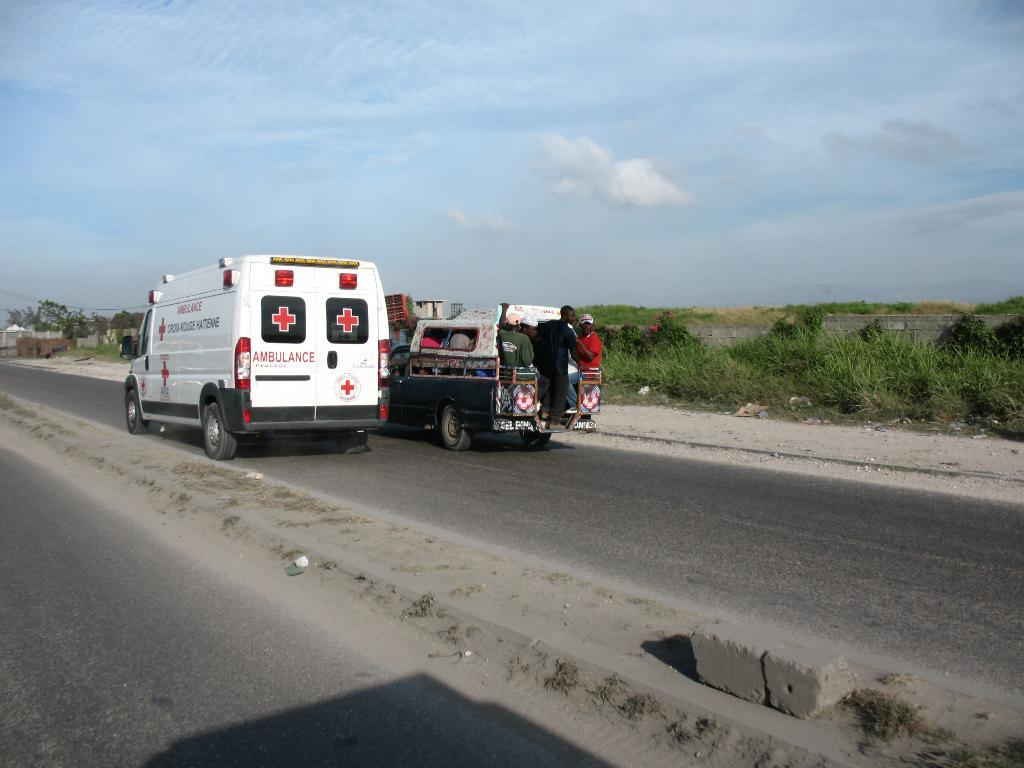What can be seen on the road in the image? There are vehicles on the road in the image. Are there any people visible in the vehicles? Yes, there are people inside a vehicle in the image. What type of vegetation is present in the image? There is grass visible in the image, as well as trees. What is visible in the background of the image? The sky is visible in the background of the image, with clouds present. Can you see any bananas hanging from the trees in the image? There are no bananas visible in the image; only grass and trees are present. Are the people in the vehicle taking a rest in the image? The image does not provide information about the actions or activities of the people inside the vehicle, so it cannot be determined if they are resting. 